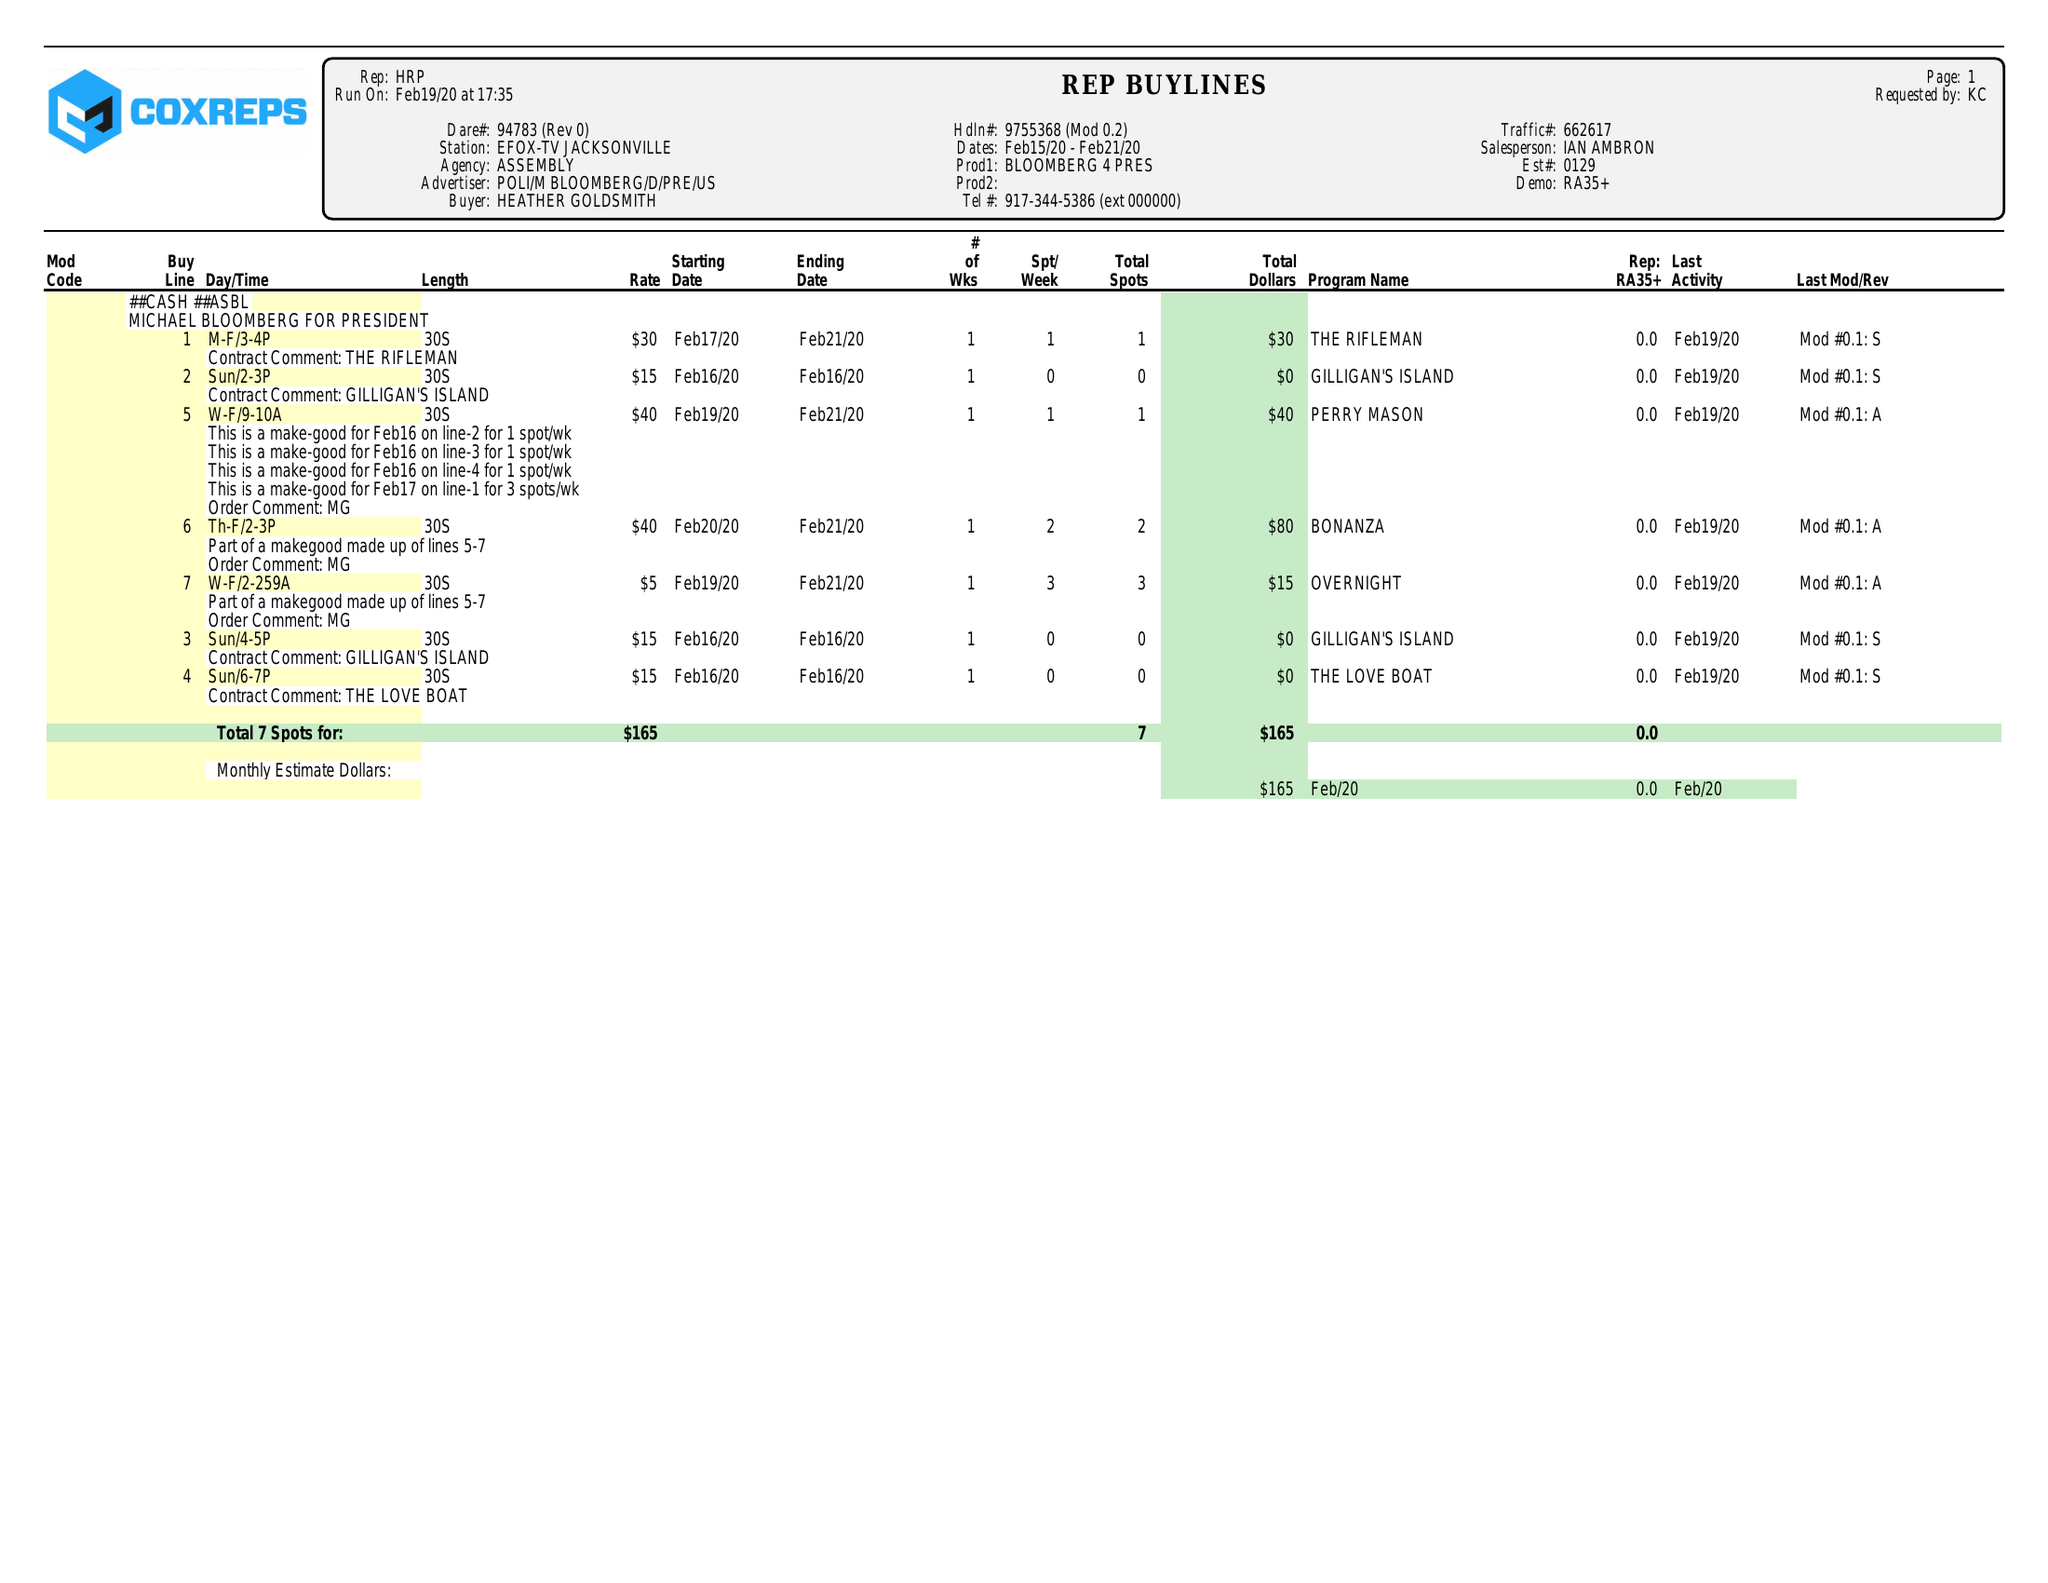What is the value for the gross_amount?
Answer the question using a single word or phrase. 165.00 